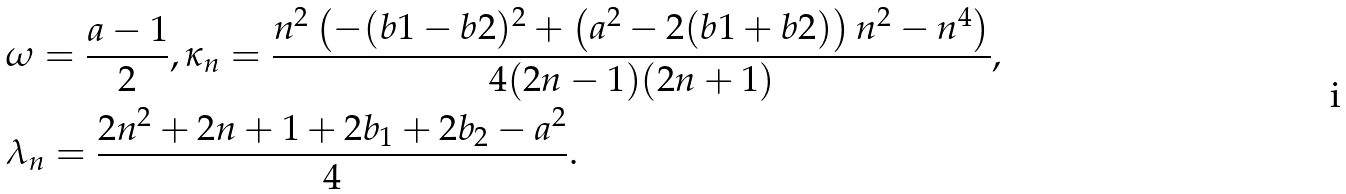Convert formula to latex. <formula><loc_0><loc_0><loc_500><loc_500>& \omega = \frac { a - 1 } { 2 } , \kappa _ { n } = \frac { n ^ { 2 } \left ( - ( b 1 - b 2 ) ^ { 2 } + \left ( a ^ { 2 } - 2 ( b 1 + b 2 ) \right ) n ^ { 2 } - n ^ { 4 } \right ) } { 4 ( 2 n - 1 ) ( 2 n + 1 ) } , \\ & \lambda _ { n } = \frac { 2 n ^ { 2 } + 2 n + 1 + 2 b _ { 1 } + 2 b _ { 2 } - a ^ { 2 } } { 4 } .</formula> 